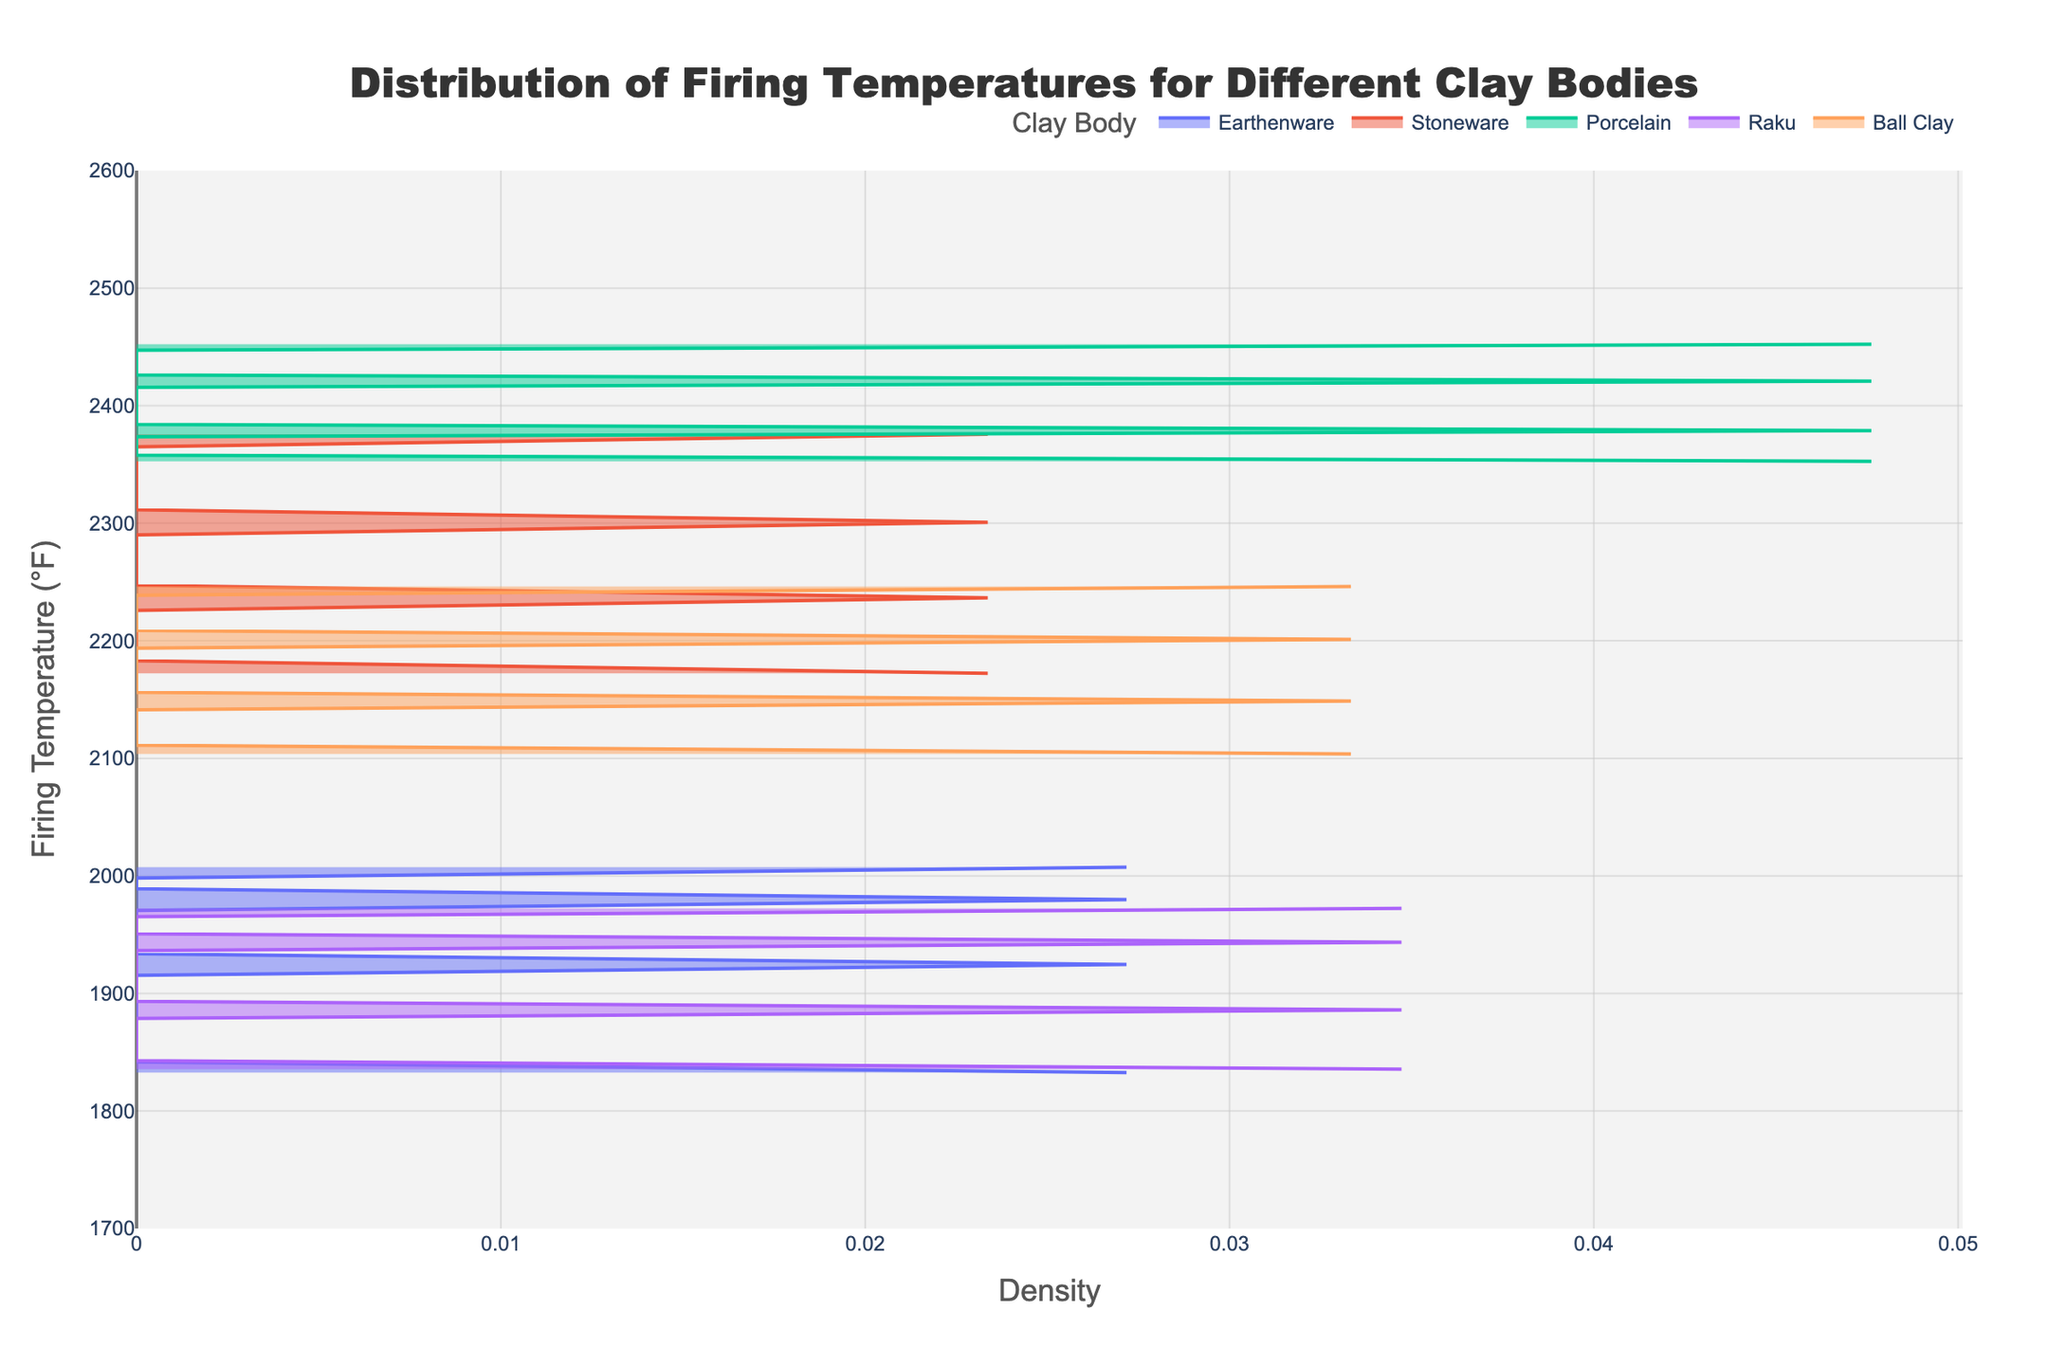What is the title of the figure? The title of the figure is typically found at the top and indicates what the figure is about. Looking at the header section, we see that it states "Distribution of Firing Temperatures for Different Clay Bodies."
Answer: Distribution of Firing Temperatures for Different Clay Bodies What does the y-axis represent in the figure? The y-axis typically represents one of the main variables being measured or compared. In this case, it shows "Firing Temperature (°F)," indicating that this axis represents the range of temperatures for firing different clay bodies.
Answer: Firing Temperature (°F) Which clay body has the highest firing temperatures according to the plot? To determine the clay body with the highest firing temperatures, look for the densest regions on the y-axis at the higher end of the temperature scale. From the sample data, Porcelain reaches higher temperatures compared to other clay bodies.
Answer: Porcelain Which clay body has the lowest firing temperatures according to the plot? To find the clay body with the lowest firing temperatures, look for the densest regions towards the lower end of the y-axis. The data suggests that Earthenware has the lowest firing temperatures among those listed.
Answer: Earthenware How do the firing temperatures of Stoneware compare to Ball Clay? Look at the density plots for Stoneware and Ball Clay. Stoneware's firing temperatures range from around 2167°F to 2381°F, whereas Ball Clay's temperatures range from 2100°F to 2250°F. Stoneware generally fires at higher temperatures compared to Ball Clay.
Answer: Stoneware has higher firing temperatures What is the range of firing temperatures for Raku? To determine the firing temperature range for Raku, look at where its density plot is concentrated on the y-axis. Raku's temperatures range from approximately 1832°F to 1976°F based on the dataset provided.
Answer: 1832°F to 1976°F Which clay body has the widest distribution of firing temperatures? To find the clay body with the widest distribution of firing temperatures, look for the clay body with the broadest range on the y-axis. Porcelain shows a wide distribution, ranging from around 2350°F to 2455°F, which is broader compared to others.
Answer: Porcelain What is the approximate median firing temperature for Earthenware? To estimate the median firing temperature for Earthenware, identify the middle value in its distribution or density peak. Earthenware's median firing temperature appears to be around 1922°F in the dataset.
Answer: 1922°F If a customer wants clay with a firing temperature around 2200°F, which clay bodies could you recommend? To recommend clay bodies with firing temperatures around 2200°F, look for those whose density peaks near this temperature on the y-axis. From the dataset, both Stoneware and Ball Clay have firing temperatures around 2200°F.
Answer: Stoneware, Ball Clay How does the appearance of the density plot help in understanding the distribution of firing temperatures? The density plot helps visualize how the firing temperatures are distributed for each clay body by showing peaks where data points are concentrated. This makes it easier to identify ranges, medians, and comparative densities without consulting raw data.
Answer: Helps visualize ranges, medians, and comparative densities 